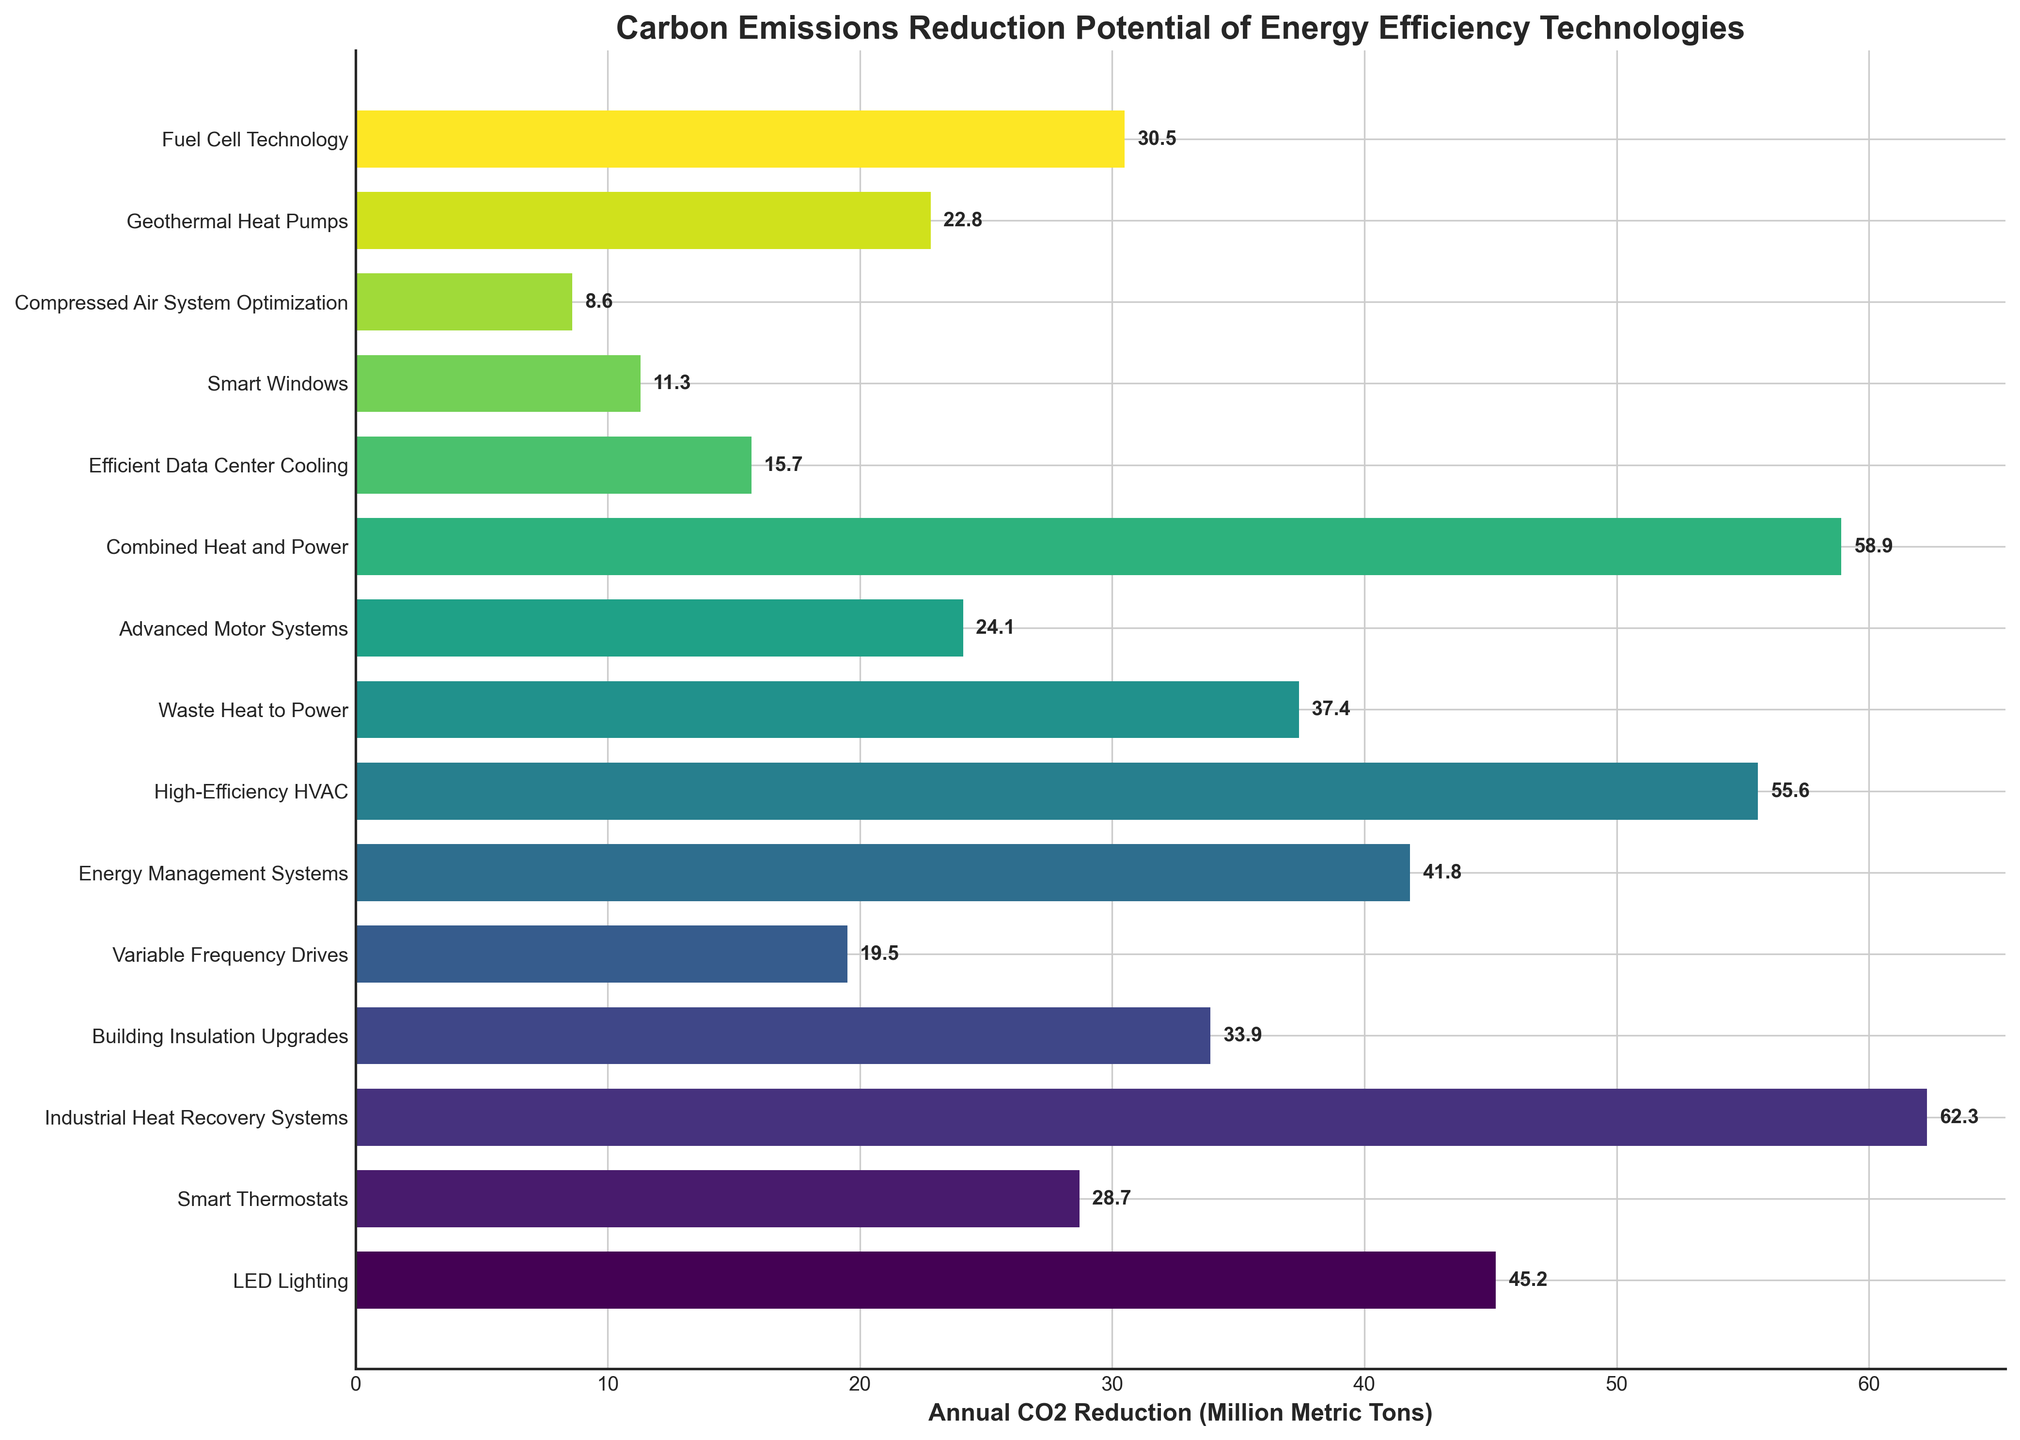Which technology offers the highest potential for carbon emissions reduction? Identify the technology with the longest bar in the chart, which represents the highest value. In this case, Industrial Heat Recovery Systems has the longest bar with 62.3 million metric tons.
Answer: Industrial Heat Recovery Systems How many technologies have a CO2 reduction potential of more than 50 million metric tons? Count the number of bars that extend beyond the 50 million metric tons mark. The technologies are Industrial Heat Recovery Systems, Combined Heat and Power, and High-Efficiency HVAC.
Answer: 3 Compare the CO2 reduction potential of LED Lighting and Smart Thermostats. Which one is higher and by how much? Find the bars corresponding to LED Lighting and Smart Thermostats. LED Lighting has 45.2 million metric tons, while Smart Thermostats have 28.7 million metric tons. The difference is 45.2 - 28.7.
Answer: LED Lighting by 16.5 What is the combined annual CO2 reduction potential of Energy Management Systems and Waste Heat to Power? Locate the bars for Energy Management Systems and Waste Heat to Power. Sum their values: 41.8 + 37.4 = 79.2.
Answer: 79.2 million metric tons Which technology has the lowest potential for CO2 reduction and what is its value? Identify the shortest bar on the chart, which represents the lowest value. Smart Windows has the shortest bar with a value of 11.3 million metric tons.
Answer: Smart Windows, 11.3 What is the average annual CO2 reduction potential for the given technologies? Sum up all the annual CO2 reduction potentials of the technologies and divide by the number of technologies. (45.2 + 28.7 + 62.3 + 33.9 + 19.5 + 41.8 + 55.6 + 37.4 + 24.1 + 58.9 + 15.7 + 11.3 + 8.6 + 22.8 + 30.5) / 15 = 37.41
Answer: 37.41 million metric tons Which technology has a CO2 reduction potential closest to the median value of all the technologies? List out all the values and find the median, which is the middle value when sorted. The median value is 30.5, corresponding to Fuel Cell Technology.
Answer: Fuel Cell Technology By how much does the CO2 reduction potential of High-Efficiency HVAC exceed that of Variable Frequency Drives? Compare the values of High-Efficiency HVAC and Variable Frequency Drives. High-Efficiency HVAC is 55.6, and Variable Frequency Drives is 19.5. The difference is 55.6 - 19.5.
Answer: 36.1 Is the CO2 reduction potential of Geothermal Heat Pumps greater than that of Advanced Motor Systems? Compare the chart values for Geothermal Heat Pumps (22.8) and Advanced Motor Systems (24.1).
Answer: No How does the length of the bar for Building Insulation Upgrades compare visually to that of Fuel Cell Technology? Observe the bars for Building Insulation Upgrades and Fuel Cell Technology. Building Insulation Upgrades has a slightly shorter bar visually compared to Fuel Cell Technology because its value is 33.9 compared to 30.5.
Answer: Shorter 